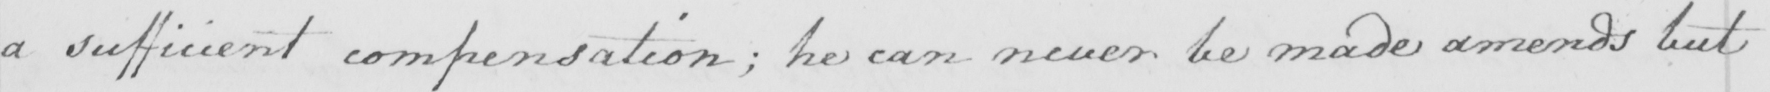Can you tell me what this handwritten text says? a sufficient compensation ; he can never be made amends but 